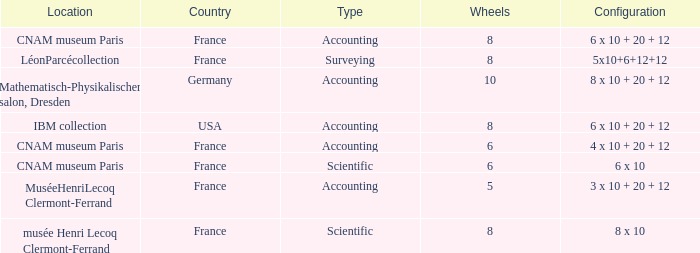Could you parse the entire table as a dict? {'header': ['Location', 'Country', 'Type', 'Wheels', 'Configuration'], 'rows': [['CNAM museum Paris', 'France', 'Accounting', '8', '6 x 10 + 20 + 12'], ['LéonParcécollection', 'France', 'Surveying', '8', '5x10+6+12+12'], ['Mathematisch-Physikalischer salon, Dresden', 'Germany', 'Accounting', '10', '8 x 10 + 20 + 12'], ['IBM collection', 'USA', 'Accounting', '8', '6 x 10 + 20 + 12'], ['CNAM museum Paris', 'France', 'Accounting', '6', '4 x 10 + 20 + 12'], ['CNAM museum Paris', 'France', 'Scientific', '6', '6 x 10'], ['MuséeHenriLecoq Clermont-Ferrand', 'France', 'Accounting', '5', '3 x 10 + 20 + 12'], ['musée Henri Lecoq Clermont-Ferrand', 'France', 'Scientific', '8', '8 x 10']]} What location has surveying as the type? LéonParcécollection. 